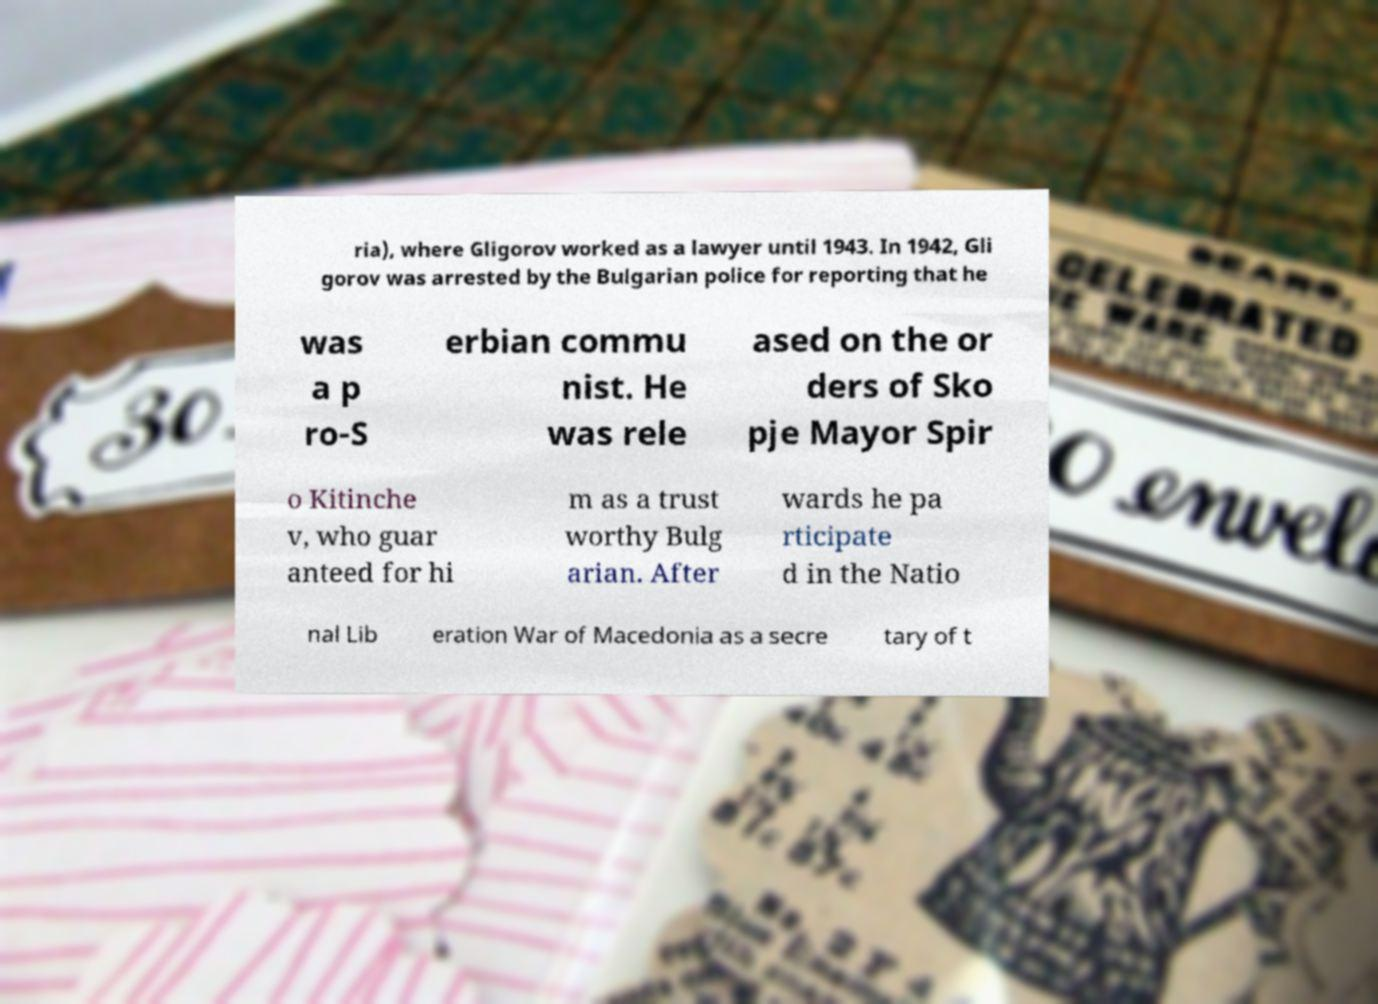Please identify and transcribe the text found in this image. ria), where Gligorov worked as a lawyer until 1943. In 1942, Gli gorov was arrested by the Bulgarian police for reporting that he was a p ro-S erbian commu nist. He was rele ased on the or ders of Sko pje Mayor Spir o Kitinche v, who guar anteed for hi m as a trust worthy Bulg arian. After wards he pa rticipate d in the Natio nal Lib eration War of Macedonia as a secre tary of t 